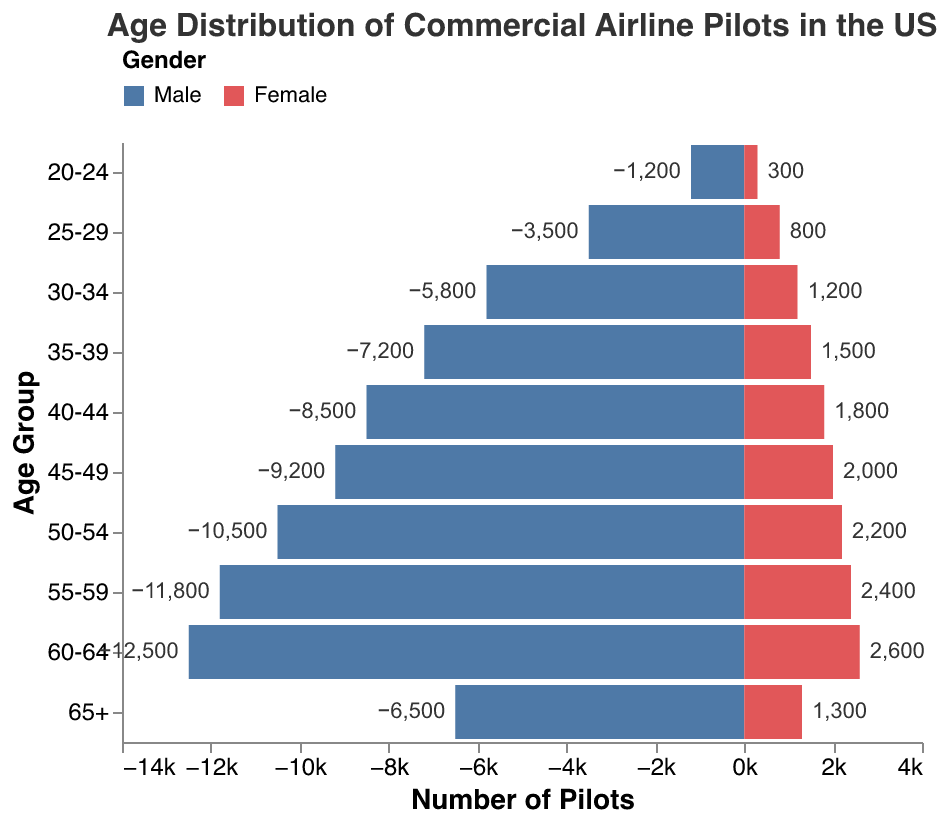What is the age group with the highest number of male pilots? Look at the bar lengths for male pilots, which are represented in blue and point to the left. The longest bar represents the 60-64 age group.
Answer: 60-64 How many more male pilots are there in the 50-54 age group compared to the female pilots in the same age group? The number of male pilots in the 50-54 age group is 10,500. The number of female pilots in the same age group is 2,200. The difference is 10,500 - 2,200.
Answer: 8,300 What is the title of the figure? The title is usually placed at the top of the figure. It reads "Age Distribution of Commercial Airline Pilots in the US".
Answer: Age Distribution of Commercial Airline Pilots in the US In which age group do we see the smallest representation of female pilots? The shortest red bar, representing female pilots, appears in the 20-24 age group.
Answer: 20-24 What is the total number of pilots in the 30-34 age group? Sum the number of male pilots (5,800) and female pilots (1,200) in the 30-34 age group.
Answer: 7,000 How does the proportion of male pilots change as age increases? Observing the blue bars' lengths, they generally increase with age until the 60-64 bracket, signifying an increasing proportion of male pilots as age increases.
Answer: Increases with age Which gender has a larger number of pilots in the 65+ age group? The blue bar to the left (representing male pilots) is longer than the red bar to the right (representing female pilots) in the 65+ age group.
Answer: Male Compare the number of pilots between the 40-44 and 45-49 age groups. Are the numbers increasing or decreasing? Compare the lengths of the bars for both male and female pilots between the two age groups. In both cases, the number of pilots increases from the 40-44 to the 45-49 age group.
Answer: Increasing 